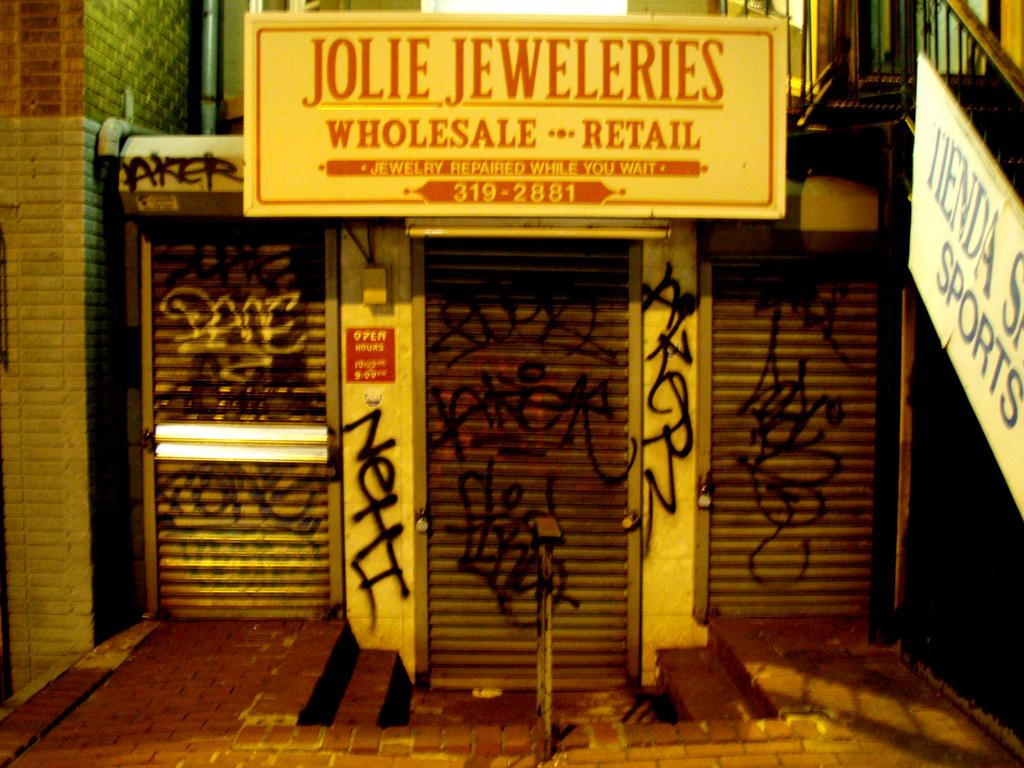<image>
Create a compact narrative representing the image presented. Jolie Jeweleries wholesale and retail store has graffiti all over the front of their security shutters. 